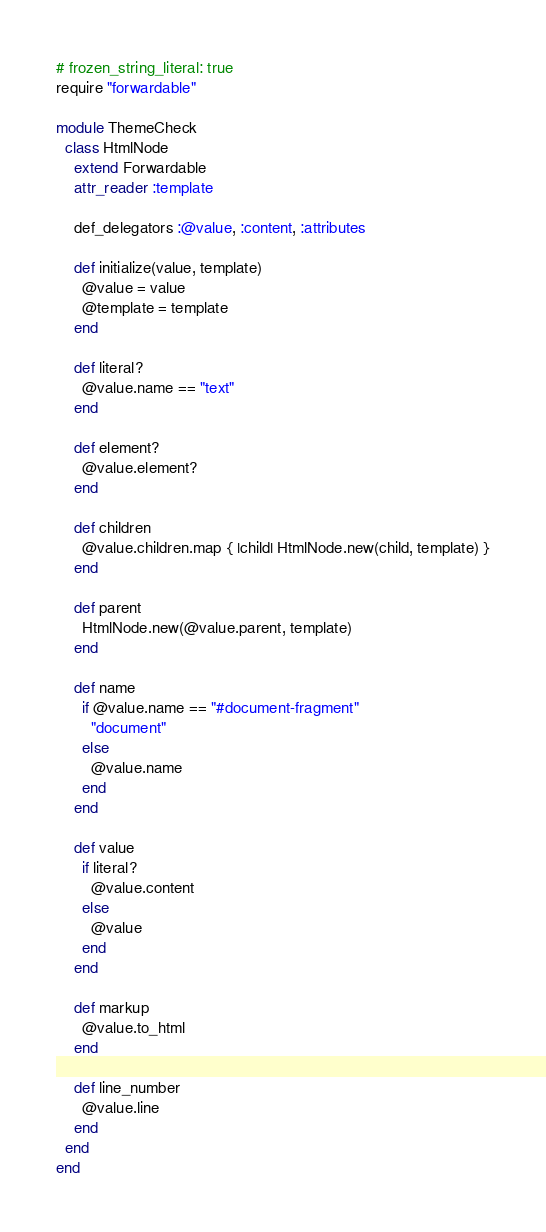Convert code to text. <code><loc_0><loc_0><loc_500><loc_500><_Ruby_># frozen_string_literal: true
require "forwardable"

module ThemeCheck
  class HtmlNode
    extend Forwardable
    attr_reader :template

    def_delegators :@value, :content, :attributes

    def initialize(value, template)
      @value = value
      @template = template
    end

    def literal?
      @value.name == "text"
    end

    def element?
      @value.element?
    end

    def children
      @value.children.map { |child| HtmlNode.new(child, template) }
    end

    def parent
      HtmlNode.new(@value.parent, template)
    end

    def name
      if @value.name == "#document-fragment"
        "document"
      else
        @value.name
      end
    end

    def value
      if literal?
        @value.content
      else
        @value
      end
    end

    def markup
      @value.to_html
    end

    def line_number
      @value.line
    end
  end
end
</code> 